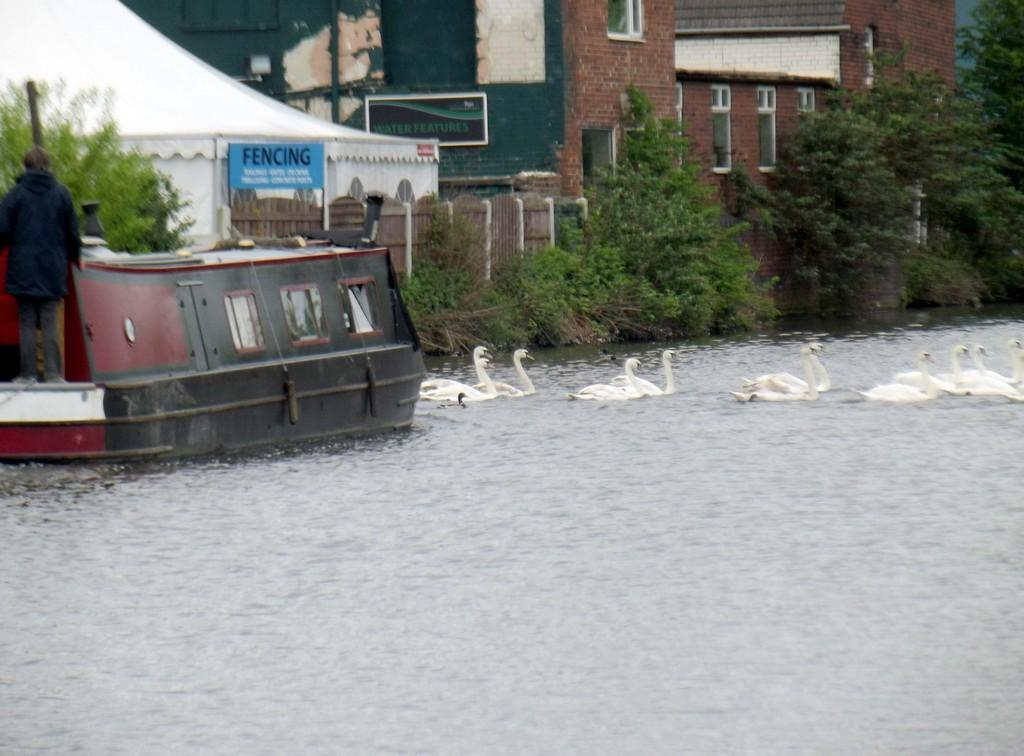What is the person in the image doing? There is a person standing on a boat in the image. What animals can be seen on the water? Swans are present on the water. What type of vegetation is visible in the background? Trees and plants are visible in the background. What structures can be seen in the background? There is a building and a wall present in the background. What type of yoke is being used by the swans in the image? There is no yoke present in the image; the swans are swimming freely on the water. 